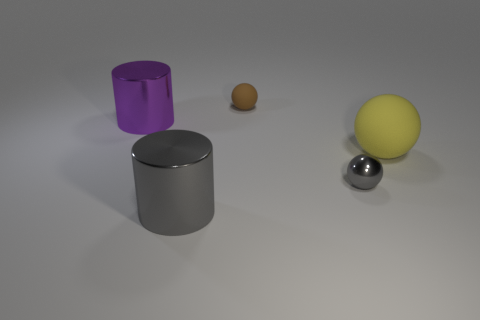There is a thing that is the same color as the small metallic sphere; what is its shape?
Give a very brief answer. Cylinder. What is the shape of the big purple shiny thing?
Your answer should be compact. Cylinder. How many cyan objects are either large things or tiny balls?
Ensure brevity in your answer.  0. What number of other objects are the same material as the big purple cylinder?
Provide a succinct answer. 2. There is a metal thing that is behind the big yellow matte thing; does it have the same shape as the tiny gray shiny object?
Your answer should be compact. No. Is there a big brown rubber ball?
Ensure brevity in your answer.  No. Is there anything else that is the same shape as the large yellow object?
Make the answer very short. Yes. Are there more purple metallic cylinders behind the small gray shiny sphere than small brown rubber things?
Your answer should be compact. No. There is a purple metallic thing; are there any big spheres to the left of it?
Ensure brevity in your answer.  No. Is the gray metal sphere the same size as the yellow object?
Offer a terse response. No. 